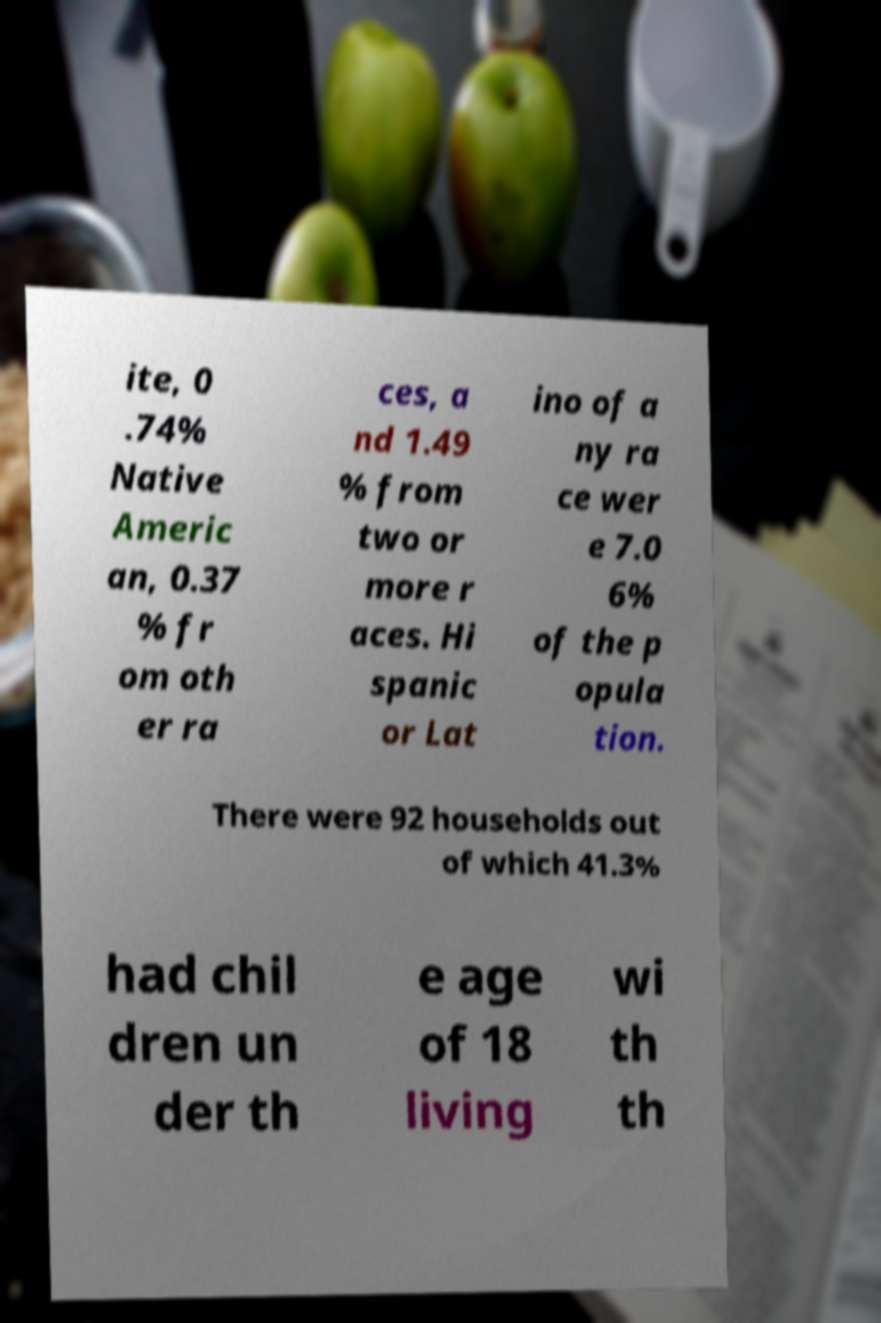Please read and relay the text visible in this image. What does it say? ite, 0 .74% Native Americ an, 0.37 % fr om oth er ra ces, a nd 1.49 % from two or more r aces. Hi spanic or Lat ino of a ny ra ce wer e 7.0 6% of the p opula tion. There were 92 households out of which 41.3% had chil dren un der th e age of 18 living wi th th 